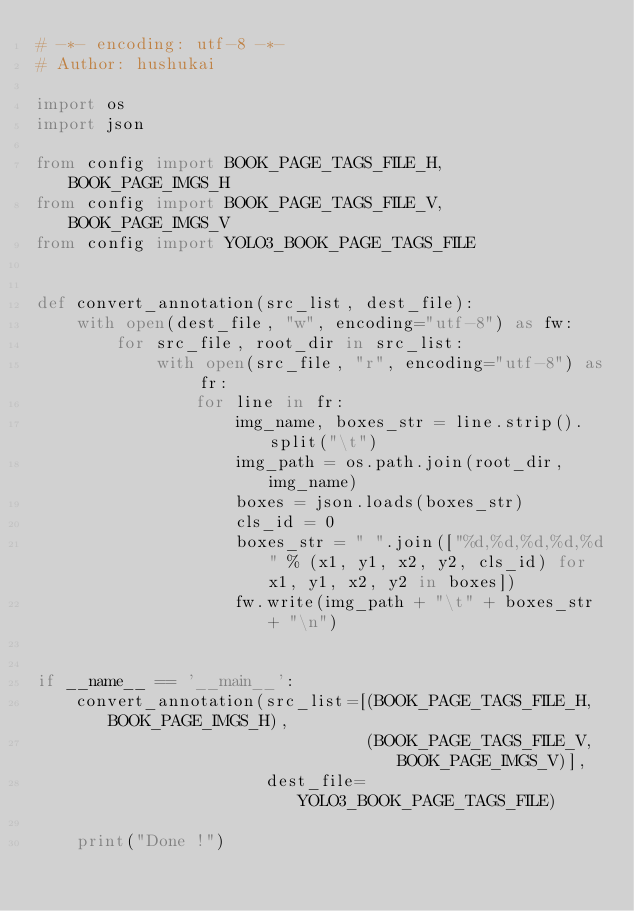Convert code to text. <code><loc_0><loc_0><loc_500><loc_500><_Python_># -*- encoding: utf-8 -*-
# Author: hushukai

import os
import json

from config import BOOK_PAGE_TAGS_FILE_H, BOOK_PAGE_IMGS_H
from config import BOOK_PAGE_TAGS_FILE_V, BOOK_PAGE_IMGS_V
from config import YOLO3_BOOK_PAGE_TAGS_FILE


def convert_annotation(src_list, dest_file):
    with open(dest_file, "w", encoding="utf-8") as fw:
        for src_file, root_dir in src_list:
            with open(src_file, "r", encoding="utf-8") as fr:
                for line in fr:
                    img_name, boxes_str = line.strip().split("\t")
                    img_path = os.path.join(root_dir, img_name)
                    boxes = json.loads(boxes_str)
                    cls_id = 0
                    boxes_str = " ".join(["%d,%d,%d,%d,%d" % (x1, y1, x2, y2, cls_id) for x1, y1, x2, y2 in boxes])
                    fw.write(img_path + "\t" + boxes_str + "\n")


if __name__ == '__main__':
    convert_annotation(src_list=[(BOOK_PAGE_TAGS_FILE_H, BOOK_PAGE_IMGS_H),
                                 (BOOK_PAGE_TAGS_FILE_V, BOOK_PAGE_IMGS_V)],
                       dest_file=YOLO3_BOOK_PAGE_TAGS_FILE)

    print("Done !")
</code> 